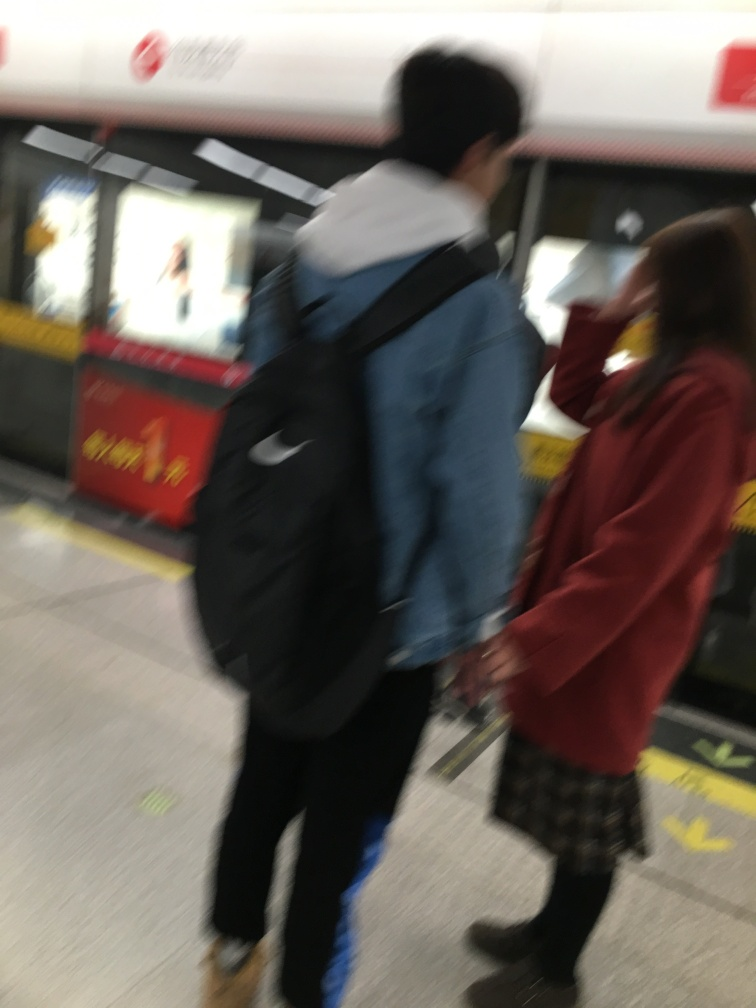What is the overall quality of this image? The image is of poor quality due to the blurriness and lack of focus, which obscures details and makes it difficult to discern fine attributes of the subjects and the environment. 